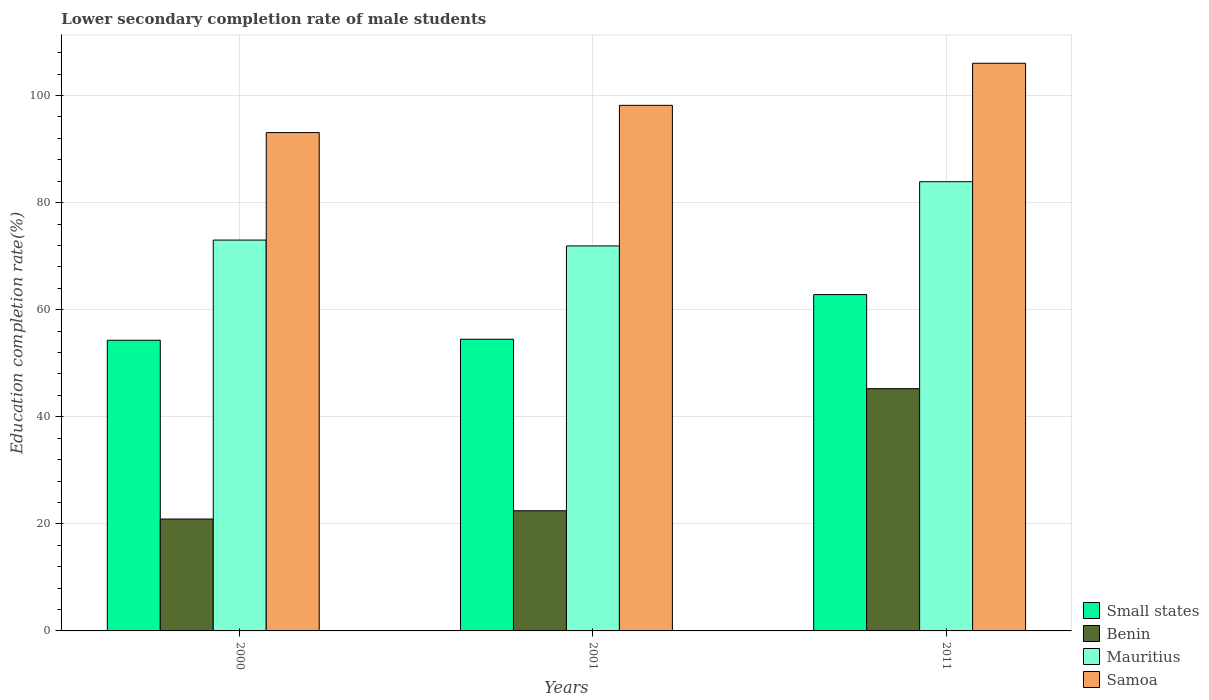How many different coloured bars are there?
Your response must be concise. 4. Are the number of bars per tick equal to the number of legend labels?
Your answer should be compact. Yes. Are the number of bars on each tick of the X-axis equal?
Provide a short and direct response. Yes. What is the label of the 1st group of bars from the left?
Offer a very short reply. 2000. In how many cases, is the number of bars for a given year not equal to the number of legend labels?
Provide a short and direct response. 0. What is the lower secondary completion rate of male students in Benin in 2011?
Your answer should be very brief. 45.25. Across all years, what is the maximum lower secondary completion rate of male students in Samoa?
Keep it short and to the point. 106.04. Across all years, what is the minimum lower secondary completion rate of male students in Small states?
Make the answer very short. 54.3. In which year was the lower secondary completion rate of male students in Mauritius minimum?
Your answer should be very brief. 2001. What is the total lower secondary completion rate of male students in Mauritius in the graph?
Your answer should be compact. 228.84. What is the difference between the lower secondary completion rate of male students in Mauritius in 2000 and that in 2011?
Offer a very short reply. -10.9. What is the difference between the lower secondary completion rate of male students in Samoa in 2000 and the lower secondary completion rate of male students in Benin in 2011?
Make the answer very short. 47.83. What is the average lower secondary completion rate of male students in Benin per year?
Provide a succinct answer. 29.53. In the year 2001, what is the difference between the lower secondary completion rate of male students in Small states and lower secondary completion rate of male students in Mauritius?
Provide a short and direct response. -17.42. In how many years, is the lower secondary completion rate of male students in Mauritius greater than 76 %?
Offer a terse response. 1. What is the ratio of the lower secondary completion rate of male students in Small states in 2000 to that in 2011?
Keep it short and to the point. 0.86. Is the difference between the lower secondary completion rate of male students in Small states in 2001 and 2011 greater than the difference between the lower secondary completion rate of male students in Mauritius in 2001 and 2011?
Your response must be concise. Yes. What is the difference between the highest and the second highest lower secondary completion rate of male students in Samoa?
Offer a terse response. 7.86. What is the difference between the highest and the lowest lower secondary completion rate of male students in Mauritius?
Offer a very short reply. 12. In how many years, is the lower secondary completion rate of male students in Samoa greater than the average lower secondary completion rate of male students in Samoa taken over all years?
Provide a short and direct response. 1. What does the 2nd bar from the left in 2001 represents?
Your answer should be compact. Benin. What does the 4th bar from the right in 2011 represents?
Your response must be concise. Small states. Is it the case that in every year, the sum of the lower secondary completion rate of male students in Small states and lower secondary completion rate of male students in Samoa is greater than the lower secondary completion rate of male students in Mauritius?
Your answer should be very brief. Yes. Are all the bars in the graph horizontal?
Ensure brevity in your answer.  No. What is the difference between two consecutive major ticks on the Y-axis?
Provide a short and direct response. 20. Does the graph contain grids?
Your answer should be very brief. Yes. How many legend labels are there?
Offer a terse response. 4. How are the legend labels stacked?
Provide a succinct answer. Vertical. What is the title of the graph?
Keep it short and to the point. Lower secondary completion rate of male students. What is the label or title of the X-axis?
Make the answer very short. Years. What is the label or title of the Y-axis?
Provide a short and direct response. Education completion rate(%). What is the Education completion rate(%) of Small states in 2000?
Your answer should be compact. 54.3. What is the Education completion rate(%) of Benin in 2000?
Your answer should be compact. 20.9. What is the Education completion rate(%) in Mauritius in 2000?
Your answer should be very brief. 73.01. What is the Education completion rate(%) in Samoa in 2000?
Make the answer very short. 93.09. What is the Education completion rate(%) in Small states in 2001?
Your answer should be compact. 54.49. What is the Education completion rate(%) in Benin in 2001?
Ensure brevity in your answer.  22.45. What is the Education completion rate(%) of Mauritius in 2001?
Keep it short and to the point. 71.91. What is the Education completion rate(%) in Samoa in 2001?
Offer a terse response. 98.18. What is the Education completion rate(%) in Small states in 2011?
Your answer should be very brief. 62.83. What is the Education completion rate(%) in Benin in 2011?
Make the answer very short. 45.25. What is the Education completion rate(%) of Mauritius in 2011?
Make the answer very short. 83.91. What is the Education completion rate(%) in Samoa in 2011?
Your response must be concise. 106.04. Across all years, what is the maximum Education completion rate(%) in Small states?
Ensure brevity in your answer.  62.83. Across all years, what is the maximum Education completion rate(%) of Benin?
Keep it short and to the point. 45.25. Across all years, what is the maximum Education completion rate(%) in Mauritius?
Ensure brevity in your answer.  83.91. Across all years, what is the maximum Education completion rate(%) of Samoa?
Provide a short and direct response. 106.04. Across all years, what is the minimum Education completion rate(%) of Small states?
Your answer should be compact. 54.3. Across all years, what is the minimum Education completion rate(%) in Benin?
Provide a succinct answer. 20.9. Across all years, what is the minimum Education completion rate(%) of Mauritius?
Provide a succinct answer. 71.91. Across all years, what is the minimum Education completion rate(%) in Samoa?
Provide a succinct answer. 93.09. What is the total Education completion rate(%) in Small states in the graph?
Offer a very short reply. 171.61. What is the total Education completion rate(%) of Benin in the graph?
Your response must be concise. 88.6. What is the total Education completion rate(%) of Mauritius in the graph?
Ensure brevity in your answer.  228.84. What is the total Education completion rate(%) in Samoa in the graph?
Keep it short and to the point. 297.3. What is the difference between the Education completion rate(%) in Small states in 2000 and that in 2001?
Offer a very short reply. -0.19. What is the difference between the Education completion rate(%) of Benin in 2000 and that in 2001?
Ensure brevity in your answer.  -1.55. What is the difference between the Education completion rate(%) of Mauritius in 2000 and that in 2001?
Your answer should be very brief. 1.1. What is the difference between the Education completion rate(%) of Samoa in 2000 and that in 2001?
Your answer should be compact. -5.09. What is the difference between the Education completion rate(%) of Small states in 2000 and that in 2011?
Offer a terse response. -8.53. What is the difference between the Education completion rate(%) of Benin in 2000 and that in 2011?
Provide a short and direct response. -24.35. What is the difference between the Education completion rate(%) in Mauritius in 2000 and that in 2011?
Give a very brief answer. -10.9. What is the difference between the Education completion rate(%) of Samoa in 2000 and that in 2011?
Provide a succinct answer. -12.95. What is the difference between the Education completion rate(%) of Small states in 2001 and that in 2011?
Ensure brevity in your answer.  -8.34. What is the difference between the Education completion rate(%) in Benin in 2001 and that in 2011?
Provide a short and direct response. -22.81. What is the difference between the Education completion rate(%) in Mauritius in 2001 and that in 2011?
Ensure brevity in your answer.  -12. What is the difference between the Education completion rate(%) in Samoa in 2001 and that in 2011?
Give a very brief answer. -7.86. What is the difference between the Education completion rate(%) of Small states in 2000 and the Education completion rate(%) of Benin in 2001?
Offer a terse response. 31.85. What is the difference between the Education completion rate(%) of Small states in 2000 and the Education completion rate(%) of Mauritius in 2001?
Your answer should be very brief. -17.61. What is the difference between the Education completion rate(%) in Small states in 2000 and the Education completion rate(%) in Samoa in 2001?
Give a very brief answer. -43.88. What is the difference between the Education completion rate(%) in Benin in 2000 and the Education completion rate(%) in Mauritius in 2001?
Make the answer very short. -51.01. What is the difference between the Education completion rate(%) of Benin in 2000 and the Education completion rate(%) of Samoa in 2001?
Provide a succinct answer. -77.28. What is the difference between the Education completion rate(%) in Mauritius in 2000 and the Education completion rate(%) in Samoa in 2001?
Keep it short and to the point. -25.17. What is the difference between the Education completion rate(%) in Small states in 2000 and the Education completion rate(%) in Benin in 2011?
Provide a short and direct response. 9.05. What is the difference between the Education completion rate(%) of Small states in 2000 and the Education completion rate(%) of Mauritius in 2011?
Your response must be concise. -29.62. What is the difference between the Education completion rate(%) in Small states in 2000 and the Education completion rate(%) in Samoa in 2011?
Offer a very short reply. -51.74. What is the difference between the Education completion rate(%) of Benin in 2000 and the Education completion rate(%) of Mauritius in 2011?
Keep it short and to the point. -63.02. What is the difference between the Education completion rate(%) in Benin in 2000 and the Education completion rate(%) in Samoa in 2011?
Offer a very short reply. -85.14. What is the difference between the Education completion rate(%) of Mauritius in 2000 and the Education completion rate(%) of Samoa in 2011?
Make the answer very short. -33.03. What is the difference between the Education completion rate(%) of Small states in 2001 and the Education completion rate(%) of Benin in 2011?
Provide a succinct answer. 9.23. What is the difference between the Education completion rate(%) in Small states in 2001 and the Education completion rate(%) in Mauritius in 2011?
Your answer should be compact. -29.43. What is the difference between the Education completion rate(%) of Small states in 2001 and the Education completion rate(%) of Samoa in 2011?
Keep it short and to the point. -51.55. What is the difference between the Education completion rate(%) of Benin in 2001 and the Education completion rate(%) of Mauritius in 2011?
Ensure brevity in your answer.  -61.47. What is the difference between the Education completion rate(%) of Benin in 2001 and the Education completion rate(%) of Samoa in 2011?
Offer a terse response. -83.59. What is the difference between the Education completion rate(%) in Mauritius in 2001 and the Education completion rate(%) in Samoa in 2011?
Make the answer very short. -34.13. What is the average Education completion rate(%) in Small states per year?
Make the answer very short. 57.2. What is the average Education completion rate(%) of Benin per year?
Make the answer very short. 29.53. What is the average Education completion rate(%) in Mauritius per year?
Offer a terse response. 76.28. What is the average Education completion rate(%) of Samoa per year?
Your answer should be compact. 99.1. In the year 2000, what is the difference between the Education completion rate(%) in Small states and Education completion rate(%) in Benin?
Ensure brevity in your answer.  33.4. In the year 2000, what is the difference between the Education completion rate(%) in Small states and Education completion rate(%) in Mauritius?
Offer a very short reply. -18.71. In the year 2000, what is the difference between the Education completion rate(%) of Small states and Education completion rate(%) of Samoa?
Ensure brevity in your answer.  -38.79. In the year 2000, what is the difference between the Education completion rate(%) in Benin and Education completion rate(%) in Mauritius?
Your response must be concise. -52.11. In the year 2000, what is the difference between the Education completion rate(%) in Benin and Education completion rate(%) in Samoa?
Ensure brevity in your answer.  -72.19. In the year 2000, what is the difference between the Education completion rate(%) in Mauritius and Education completion rate(%) in Samoa?
Offer a terse response. -20.08. In the year 2001, what is the difference between the Education completion rate(%) in Small states and Education completion rate(%) in Benin?
Your answer should be compact. 32.04. In the year 2001, what is the difference between the Education completion rate(%) of Small states and Education completion rate(%) of Mauritius?
Make the answer very short. -17.42. In the year 2001, what is the difference between the Education completion rate(%) of Small states and Education completion rate(%) of Samoa?
Your answer should be very brief. -43.69. In the year 2001, what is the difference between the Education completion rate(%) of Benin and Education completion rate(%) of Mauritius?
Ensure brevity in your answer.  -49.46. In the year 2001, what is the difference between the Education completion rate(%) of Benin and Education completion rate(%) of Samoa?
Provide a short and direct response. -75.73. In the year 2001, what is the difference between the Education completion rate(%) in Mauritius and Education completion rate(%) in Samoa?
Your response must be concise. -26.27. In the year 2011, what is the difference between the Education completion rate(%) of Small states and Education completion rate(%) of Benin?
Keep it short and to the point. 17.57. In the year 2011, what is the difference between the Education completion rate(%) of Small states and Education completion rate(%) of Mauritius?
Offer a very short reply. -21.09. In the year 2011, what is the difference between the Education completion rate(%) in Small states and Education completion rate(%) in Samoa?
Ensure brevity in your answer.  -43.21. In the year 2011, what is the difference between the Education completion rate(%) in Benin and Education completion rate(%) in Mauritius?
Provide a short and direct response. -38.66. In the year 2011, what is the difference between the Education completion rate(%) in Benin and Education completion rate(%) in Samoa?
Your answer should be very brief. -60.78. In the year 2011, what is the difference between the Education completion rate(%) of Mauritius and Education completion rate(%) of Samoa?
Your answer should be compact. -22.12. What is the ratio of the Education completion rate(%) in Small states in 2000 to that in 2001?
Keep it short and to the point. 1. What is the ratio of the Education completion rate(%) of Benin in 2000 to that in 2001?
Ensure brevity in your answer.  0.93. What is the ratio of the Education completion rate(%) in Mauritius in 2000 to that in 2001?
Keep it short and to the point. 1.02. What is the ratio of the Education completion rate(%) of Samoa in 2000 to that in 2001?
Keep it short and to the point. 0.95. What is the ratio of the Education completion rate(%) of Small states in 2000 to that in 2011?
Ensure brevity in your answer.  0.86. What is the ratio of the Education completion rate(%) of Benin in 2000 to that in 2011?
Offer a terse response. 0.46. What is the ratio of the Education completion rate(%) of Mauritius in 2000 to that in 2011?
Give a very brief answer. 0.87. What is the ratio of the Education completion rate(%) of Samoa in 2000 to that in 2011?
Make the answer very short. 0.88. What is the ratio of the Education completion rate(%) in Small states in 2001 to that in 2011?
Your response must be concise. 0.87. What is the ratio of the Education completion rate(%) of Benin in 2001 to that in 2011?
Your answer should be very brief. 0.5. What is the ratio of the Education completion rate(%) in Mauritius in 2001 to that in 2011?
Keep it short and to the point. 0.86. What is the ratio of the Education completion rate(%) in Samoa in 2001 to that in 2011?
Make the answer very short. 0.93. What is the difference between the highest and the second highest Education completion rate(%) of Small states?
Offer a terse response. 8.34. What is the difference between the highest and the second highest Education completion rate(%) in Benin?
Give a very brief answer. 22.81. What is the difference between the highest and the second highest Education completion rate(%) in Mauritius?
Your answer should be very brief. 10.9. What is the difference between the highest and the second highest Education completion rate(%) in Samoa?
Make the answer very short. 7.86. What is the difference between the highest and the lowest Education completion rate(%) of Small states?
Keep it short and to the point. 8.53. What is the difference between the highest and the lowest Education completion rate(%) in Benin?
Offer a terse response. 24.35. What is the difference between the highest and the lowest Education completion rate(%) in Mauritius?
Offer a very short reply. 12. What is the difference between the highest and the lowest Education completion rate(%) of Samoa?
Offer a very short reply. 12.95. 